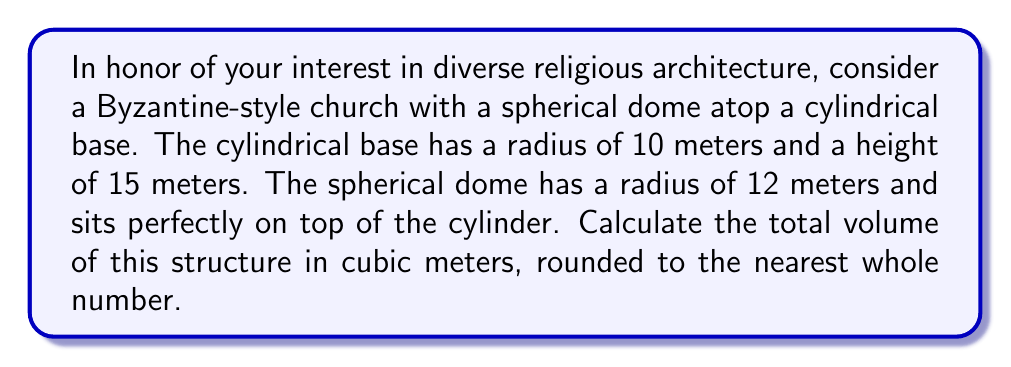Can you solve this math problem? Let's approach this step-by-step:

1. Calculate the volume of the cylindrical base:
   $$V_{cylinder} = \pi r^2 h$$
   where $r$ is the radius and $h$ is the height
   $$V_{cylinder} = \pi \cdot 10^2 \cdot 15 = 1500\pi \text{ m}^3$$

2. Calculate the volume of a full sphere with radius 12 m:
   $$V_{full\,sphere} = \frac{4}{3}\pi r^3$$
   $$V_{full\,sphere} = \frac{4}{3}\pi \cdot 12^3 = 2304\pi \text{ m}^3$$

3. Calculate the volume of the spherical cap (the part of the sphere that forms the dome):
   First, we need to find the height of the spherical cap. The radius of the base of the cap is 10 m (same as the cylinder), and the radius of the sphere is 12 m.
   Using the Pythagorean theorem:
   $$h = 12 - \sqrt{12^2 - 10^2} = 12 - \sqrt{44} \approx 5.3589 \text{ m}$$

   Now we can use the formula for the volume of a spherical cap:
   $$V_{cap} = \frac{1}{3}\pi h^2(3r - h)$$
   $$V_{cap} = \frac{1}{3}\pi \cdot 5.3589^2(3 \cdot 12 - 5.3589) \approx 950.7327\pi \text{ m}^3$$

4. Calculate the total volume by adding the cylinder and the spherical cap:
   $$V_{total} = V_{cylinder} + V_{cap}$$
   $$V_{total} = 1500\pi + 950.7327\pi = 2450.7327\pi \text{ m}^3$$

5. Convert to a numerical value and round to the nearest whole number:
   $$V_{total} \approx 7697 \text{ m}^3$$

[asy]
import geometry;

size(200);
draw(circle((0,0),10));
draw((-10,0)--(10,0));
draw((-10,0)--(-10,15)--(10,15)--(10,0));
draw(arc((0,15),12,180,360),dashed);
draw((0,15)--(0,27));
label("10m",(-5,0),S);
label("15m",(-10,7.5),W);
label("12m",(0,21),E);
[/asy]
Answer: 7697 m³ 